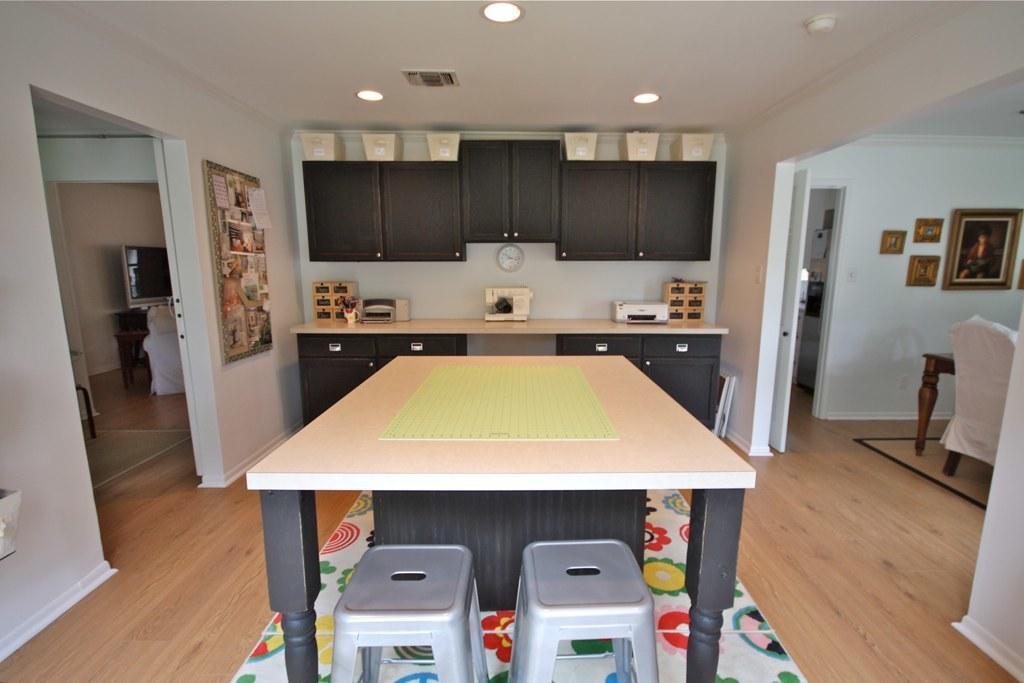In one or two sentences, can you explain what this image depicts? In this image I can see the tables, stools, cupboards, chair, doors and few objects on the table. At the top I can see few lights, ceiling and few frames, board, clock are attached to the white color wall. In the background I can see the screen and few objects. 